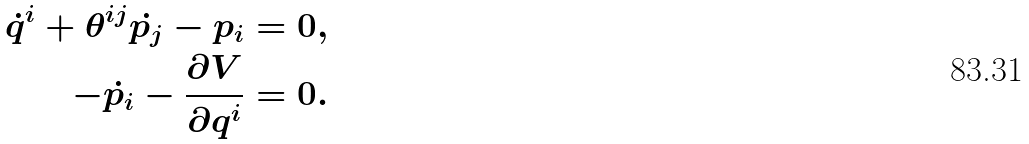<formula> <loc_0><loc_0><loc_500><loc_500>\dot { q } ^ { i } + \theta ^ { i j } \dot { p _ { j } } - p _ { i } = 0 , \\ - \dot { p _ { i } } - \frac { \partial V } { \partial q ^ { i } } = 0 .</formula> 